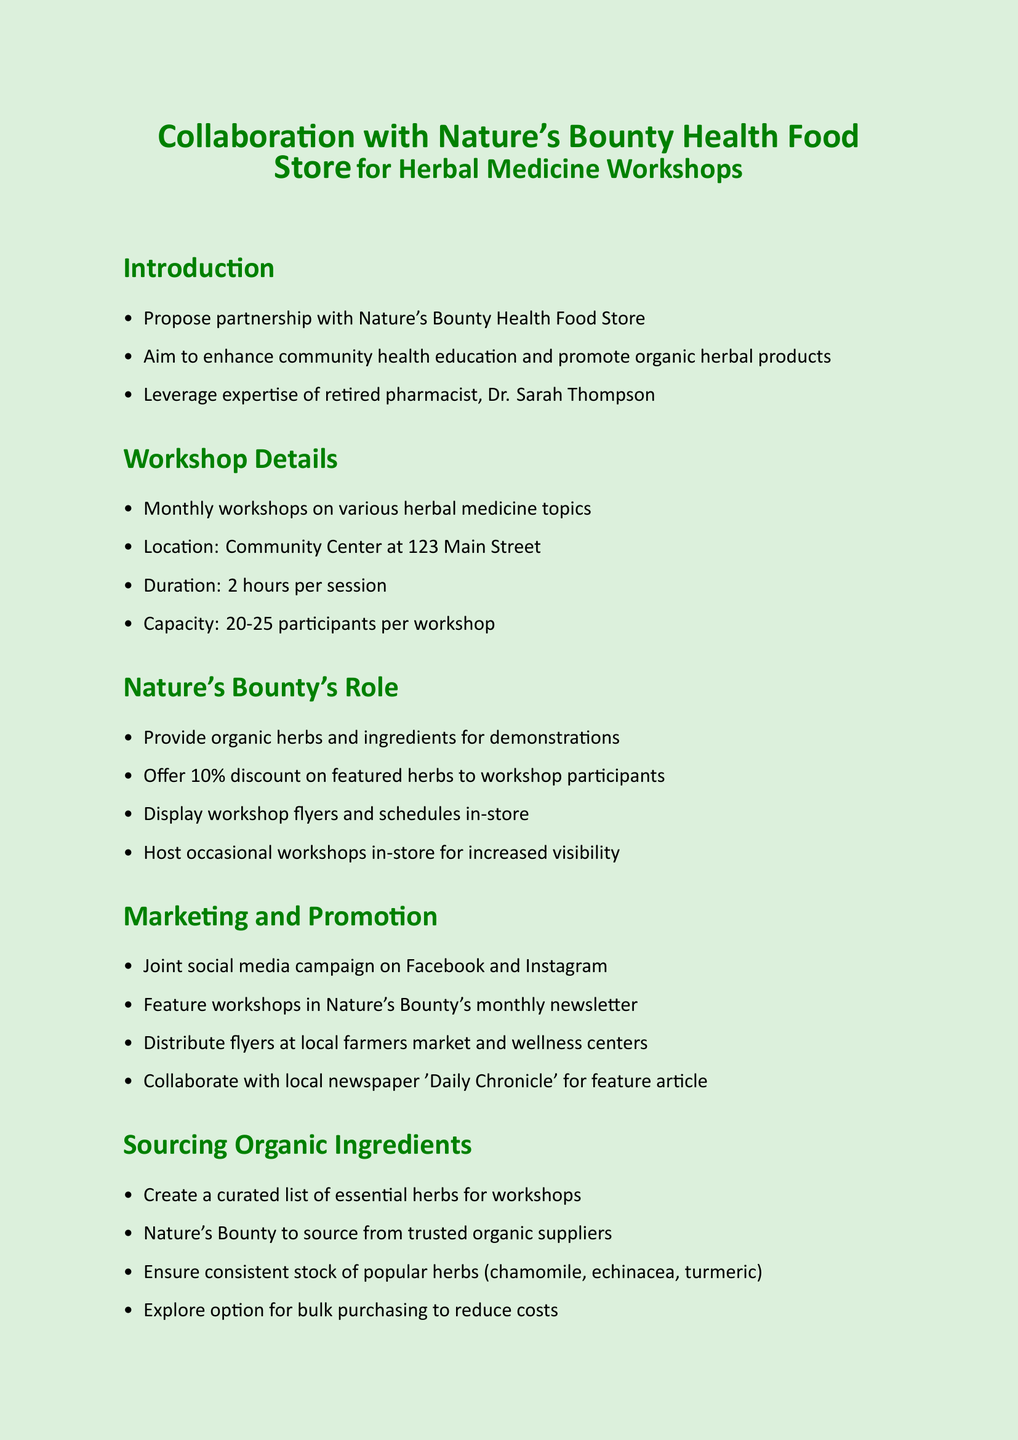what is the title of the memo? The title of the memo is prominently presented at the beginning, stating the purpose of the document, which is about collaboration for workshops.
Answer: Collaboration with Nature's Bounty Health Food Store for Herbal Medicine Workshops who is the retired pharmacist mentioned in the document? The document specifies the collaboration will leverage the expertise of a specific retired pharmacist.
Answer: Dr. Sarah Thompson how long is each workshop session? The duration of each session is clearly stated in the workshop details section.
Answer: 2 hours how many participants can attend each workshop? The document specifies the capacity limit for each workshop.
Answer: 20-25 participants what discount will Nature's Bounty offer to workshop participants? The specific discount offered is mentioned in the role of Nature's Bounty in the workshops section.
Answer: 10% what is one of the essential herbs mentioned for sourcing? The document lists certain popular herbs that will be sourced for the workshops, among which one is explicitly mentioned.
Answer: chamomile what community benefit is identified in the memo? The document outlines several community benefits associated with the collaboration, focusing on awareness of herbal medicine.
Answer: Increase awareness of herbal medicine benefits what is the next step after scheduling a meeting with the owner? The document lists sequential next steps to be taken following the meeting schedule.
Answer: Finalize workshop topics and schedule for next quarter how will the workshops be promoted? A combination of marketing strategies is proposed in the document for promoting the workshops.
Answer: Joint social media campaign on Facebook and Instagram 